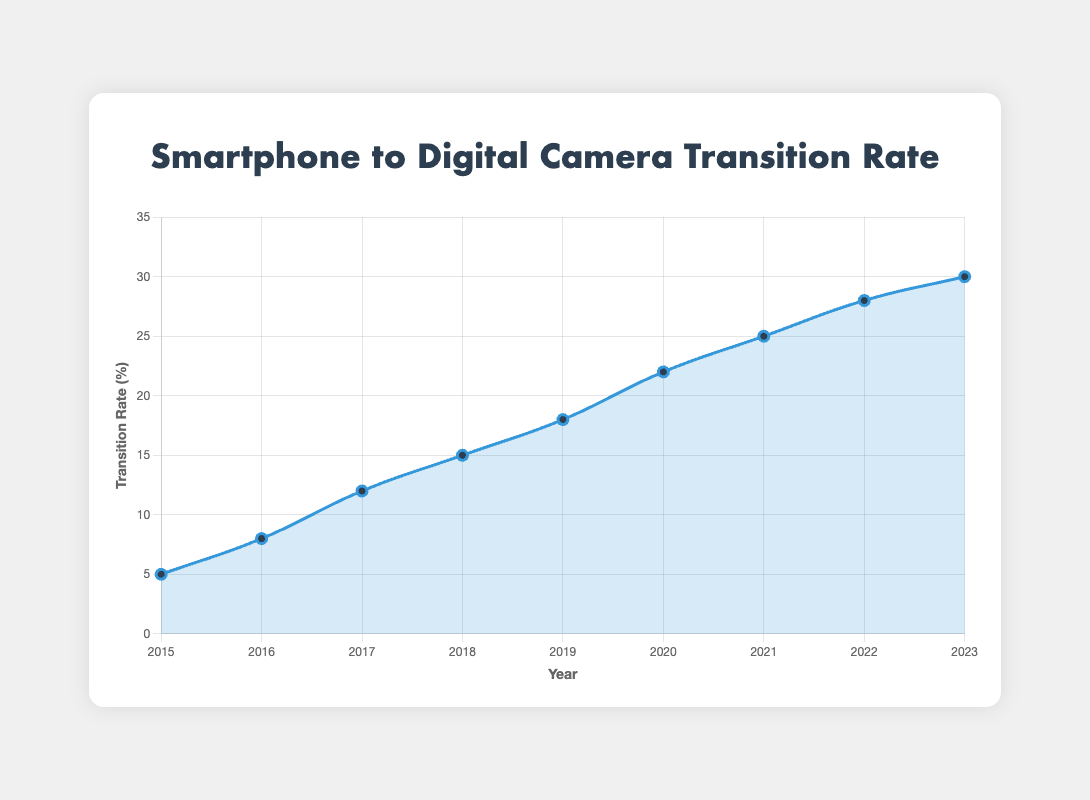What is the transition rate in 2020? Locate the point on the plot corresponding to the year 2020; the y-axis value for this point is the transition rate.
Answer: 22% Which year had the highest transition rate? Look at all the points on the plot and identify which one is the highest in value. Check the corresponding year on the x-axis.
Answer: 2023 How much did the transition rate increase from 2015 to 2016? Find the values for 2015 (5%) and 2016 (8%), then calculate the difference. 8% - 5% = 3%
Answer: 3% Compare the average spending in USD from 2017 to 2019. Which year had the highest spending? Locate the years 2017, 2018, and 2019 on the plot. Then note the respective average spending values which are $580, $600, and $620. The highest spending occurs in 2019.
Answer: 2019 What was the reason mentioned for transitioning to dedicated digital cameras in 2018 that was not mentioned in 2017? Compare the common reasons listed for 2017 and 2018. The reason "Professional features" is listed in 2018 but not in 2017.
Answer: Professional features Find the average transition rate over the period from 2015 to 2023. Sum up the transition rates from each year: (5 + 8 + 12 + 15 + 18 + 22 + 25 + 28 + 30) = 163. Divide this sum by the number of years (9). 163 / 9 ≈ 18.11
Answer: 18.11% From 2021 to 2023, what were the additional brands observed compared to the initial period (2015-2020)? Review the top brands for 2021-2023 and compare them to the brands listed in the earlier period. The additional brands are Panasonic and Olympus.
Answer: Panasonic, Olympus What is the slope of the trend line from 2016 to 2020? Calculate the rise over run using transition rates for 2016 (8%) and 2020 (22%) over these 4 years. The slope is (22-8)/(2020-2016) = 14/4 = 3.5.
Answer: 3.5 Identify the year with the sharpest increase in transition rate. Find the year with the largest year-over-year increase by calculating the differences between consecutive years and identifying the largest. From 2016 to 2017, the increase was 4%, but from 2019 to 2020, it was 22% - 18% = 4%. Therefore, both increments (2016-2017 and 2019-2020) are the same.
Answer: 2017, 2020 